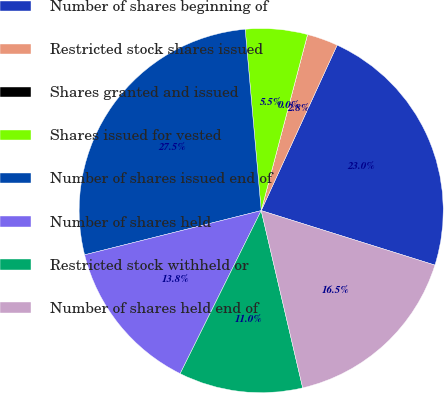Convert chart to OTSL. <chart><loc_0><loc_0><loc_500><loc_500><pie_chart><fcel>Number of shares beginning of<fcel>Restricted stock shares issued<fcel>Shares granted and issued<fcel>Shares issued for vested<fcel>Number of shares issued end of<fcel>Number of shares held<fcel>Restricted stock withheld or<fcel>Number of shares held end of<nl><fcel>22.99%<fcel>2.75%<fcel>0.0%<fcel>5.5%<fcel>27.5%<fcel>13.75%<fcel>11.0%<fcel>16.5%<nl></chart> 